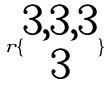<formula> <loc_0><loc_0><loc_500><loc_500>r \{ \begin{matrix} 3 , 3 , 3 \\ 3 \end{matrix} \}</formula> 